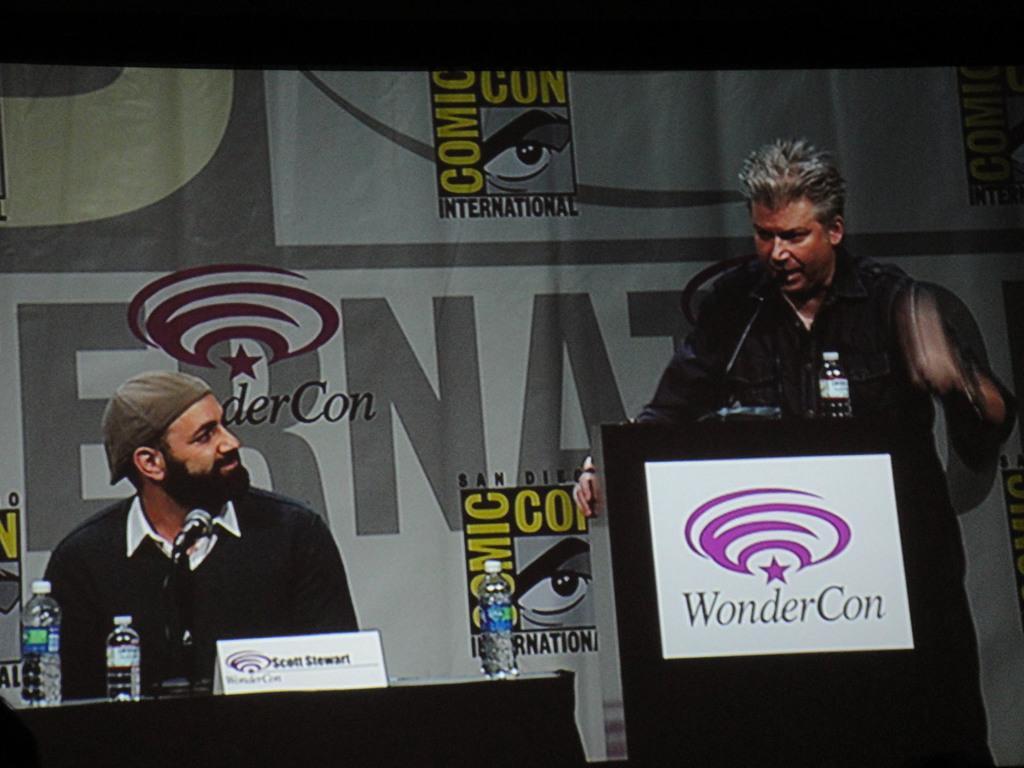Can you describe this image briefly? The man on the left side who is wearing a black shirt is standing. In front of him, we see a podium on which water bottle and microphone are placed. He is talking on the microphone. On the left side, we see a man in black jacket is sitting on the chair. He is smiling. In front of him, we see a table on which water bottles and name board are placed. In the background, we see a banner with some text written on it. 